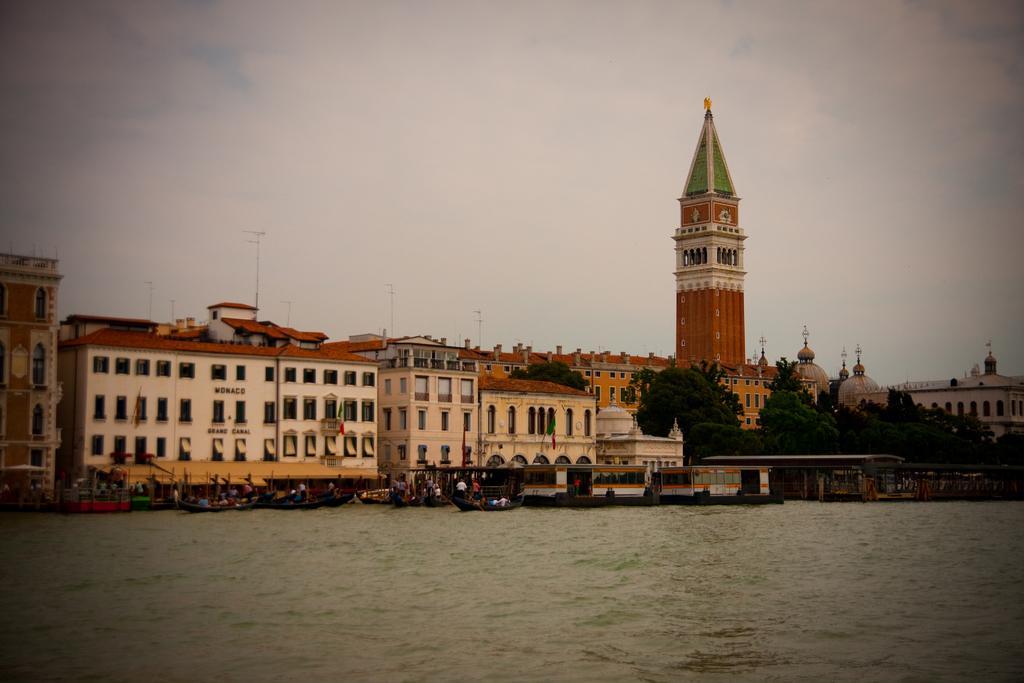Can you describe this image briefly? In this image there are boats on the water, there are group of people, there are buildings, trees ,a clock tower, and in the background there is sky. 